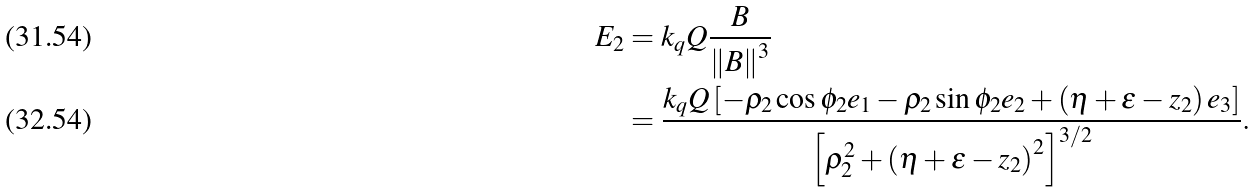<formula> <loc_0><loc_0><loc_500><loc_500>E _ { 2 } & = k _ { q } Q \frac { B } { \left \| B \right \| ^ { 3 } } \\ & = \frac { k _ { q } Q \left [ - \rho _ { 2 } \cos \phi _ { 2 } e _ { 1 } - \rho _ { 2 } \sin \phi _ { 2 } e _ { 2 } + \left ( \eta + \varepsilon - z _ { 2 } \right ) e _ { 3 } \right ] } { \left [ \rho _ { 2 } ^ { 2 } + \left ( \eta + \varepsilon - z _ { 2 } \right ) ^ { 2 } \right ] ^ { 3 / 2 } } .</formula> 